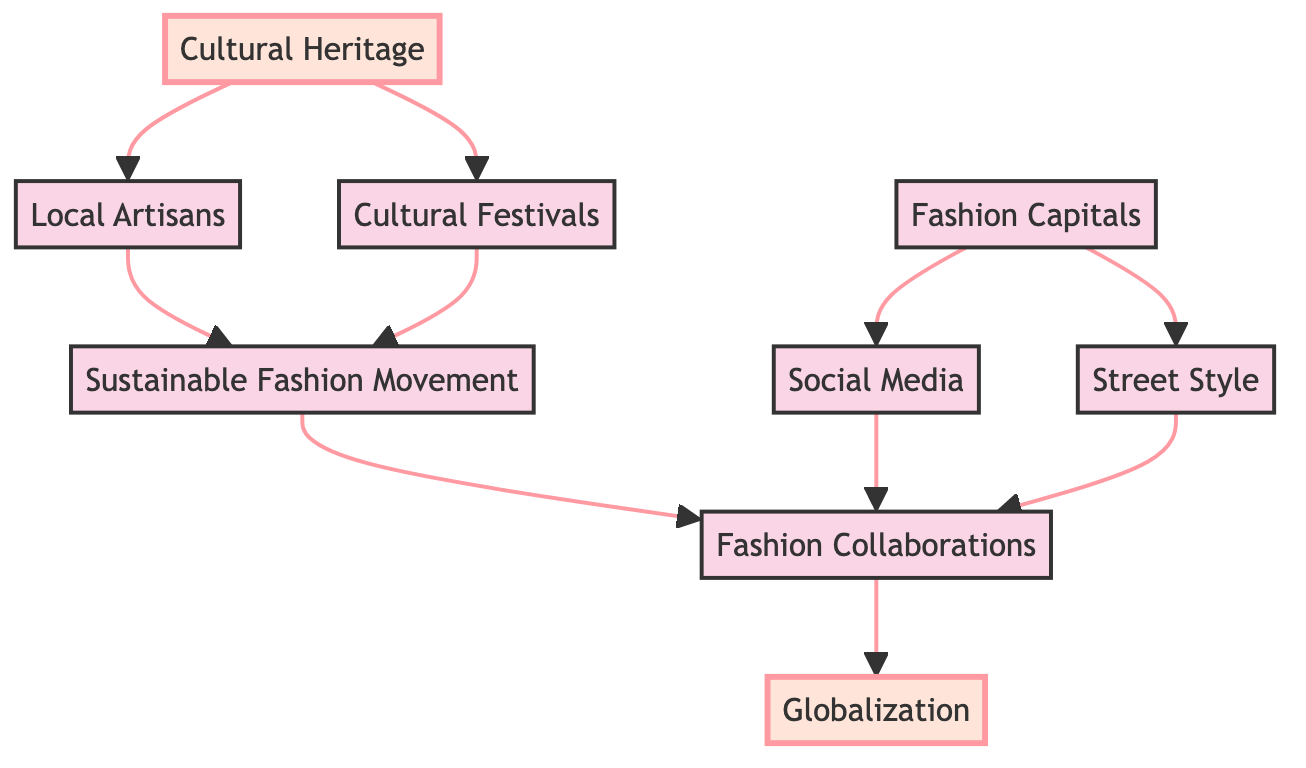What is the starting point of the flowchart? The starting point of the flowchart is "Cultural Heritage." It is represented at the top of the diagram, from which multiple arrows branch out to various related elements.
Answer: Cultural Heritage How many main elements are there in the diagram? The diagram contains a total of nine main elements, including "Cultural Heritage," "Local Artisans," "Cultural Festivals," "Sustainable Fashion Movement," "Fashion Collaborations," "Fashion Capitals," "Social Media," "Street Style," and "Globalization."
Answer: 9 What links "Local Artisans" to "Sustainable Fashion Movement"? "Local Artisans" is linked to "Sustainable Fashion Movement" because skilled craftsmen preserve traditional techniques that contribute to the movement focused on ethical practices. The arrow indicates a direct influence or relationship.
Answer: Local Artisans Which two elements lead to “Fashion Collaborations”? The two elements that lead to "Fashion Collaborations" are "Sustainable Fashion Movement" and "Cultural Festivals." Both elements have arrows pointing towards "Fashion Collaborations," indicating they both influence this outcome.
Answer: Sustainable Fashion Movement and Cultural Festivals What is the end point of the flowchart? The end point of the flowchart is "Globalization." This is the final element in the diagram where all influences converge, illustrating the result of various cultural factors merging into new trends.
Answer: Globalization How do “Fashion Capitals” influence “Social Media”? “Fashion Capitals” influence “Social Media” as they are pivotal locations for fashion content, with trends emerging from cities like Paris, Milan, and New York, which are then disseminated through social media platforms.
Answer: Fashion Capitals How many routes lead to "Globalization"? There are three routes leading to "Globalization" in the flowchart: from "Fashion Collaborations," "Cultural Festivals," and "Sustainable Fashion Movement." Each route shows a different source of influence contributing to globalization.
Answer: 3 What influences "Fashion Collaborations"? "Fashion Collaborations" is influenced by two elements: "Sustainable Fashion Movement" and "Social Media." Both contribute to the creation and popularity of collaborative styles.
Answer: Sustainable Fashion Movement and Social Media Which element is highlighted as a central concept in the flowchart? "Cultural Heritage" is highlighted as a central concept in the flowchart, indicated by its distinct style and positioning as the starting point. Its prominence suggests its foundational role in influencing fashion trends.
Answer: Cultural Heritage 